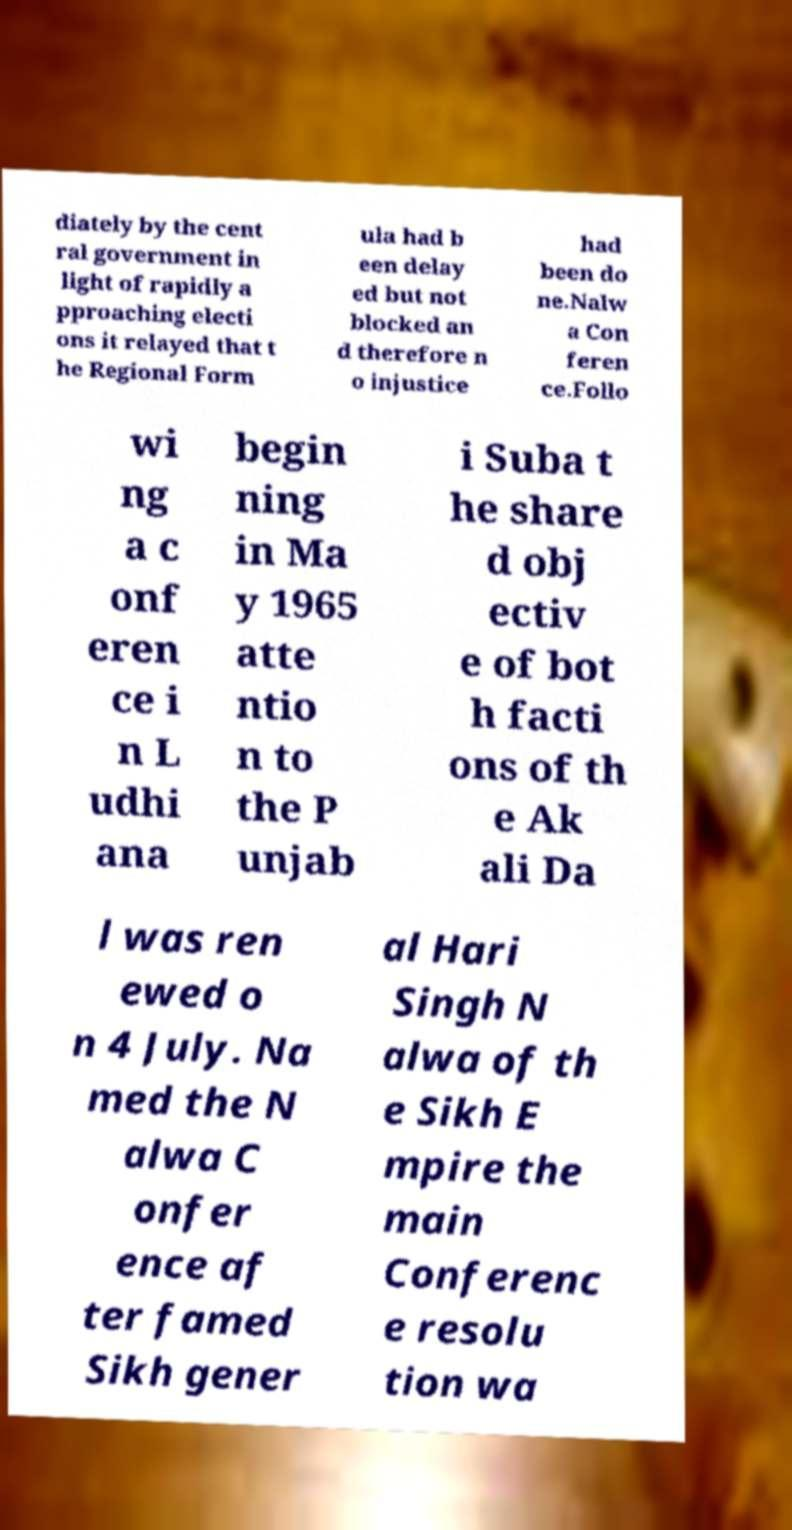Could you extract and type out the text from this image? diately by the cent ral government in light of rapidly a pproaching electi ons it relayed that t he Regional Form ula had b een delay ed but not blocked an d therefore n o injustice had been do ne.Nalw a Con feren ce.Follo wi ng a c onf eren ce i n L udhi ana begin ning in Ma y 1965 atte ntio n to the P unjab i Suba t he share d obj ectiv e of bot h facti ons of th e Ak ali Da l was ren ewed o n 4 July. Na med the N alwa C onfer ence af ter famed Sikh gener al Hari Singh N alwa of th e Sikh E mpire the main Conferenc e resolu tion wa 